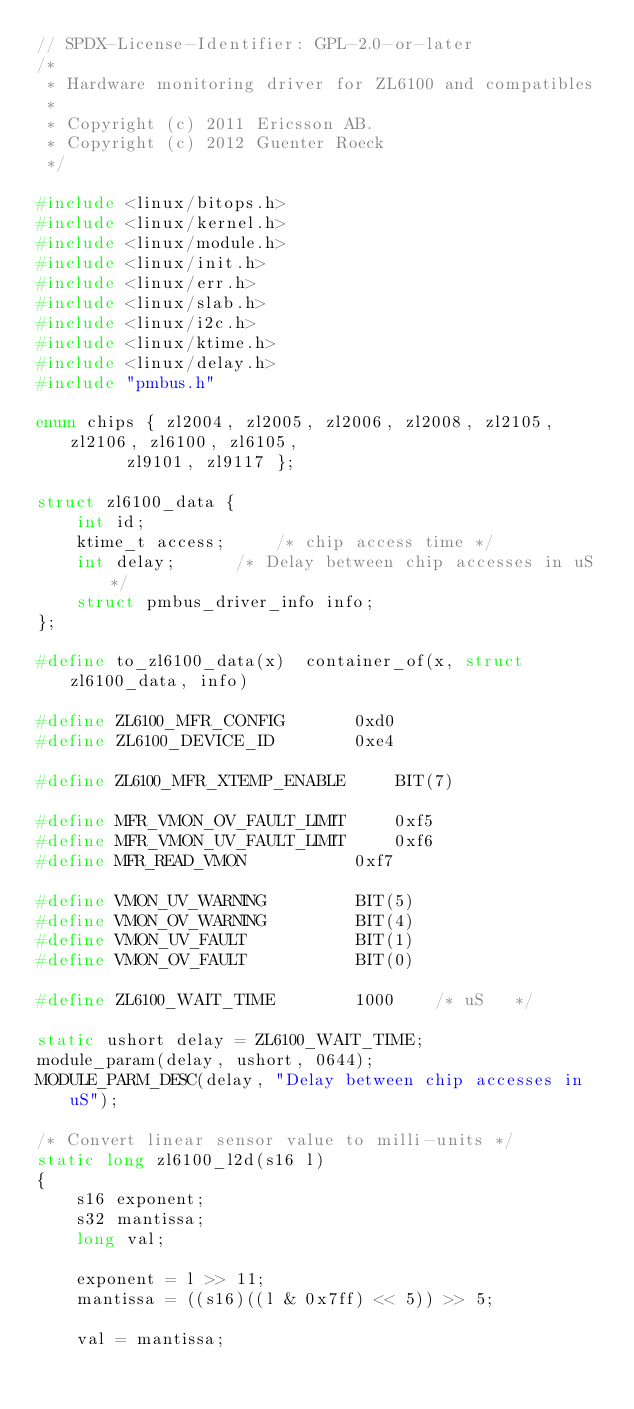Convert code to text. <code><loc_0><loc_0><loc_500><loc_500><_C_>// SPDX-License-Identifier: GPL-2.0-or-later
/*
 * Hardware monitoring driver for ZL6100 and compatibles
 *
 * Copyright (c) 2011 Ericsson AB.
 * Copyright (c) 2012 Guenter Roeck
 */

#include <linux/bitops.h>
#include <linux/kernel.h>
#include <linux/module.h>
#include <linux/init.h>
#include <linux/err.h>
#include <linux/slab.h>
#include <linux/i2c.h>
#include <linux/ktime.h>
#include <linux/delay.h>
#include "pmbus.h"

enum chips { zl2004, zl2005, zl2006, zl2008, zl2105, zl2106, zl6100, zl6105,
	     zl9101, zl9117 };

struct zl6100_data {
	int id;
	ktime_t access;		/* chip access time */
	int delay;		/* Delay between chip accesses in uS */
	struct pmbus_driver_info info;
};

#define to_zl6100_data(x)  container_of(x, struct zl6100_data, info)

#define ZL6100_MFR_CONFIG		0xd0
#define ZL6100_DEVICE_ID		0xe4

#define ZL6100_MFR_XTEMP_ENABLE		BIT(7)

#define MFR_VMON_OV_FAULT_LIMIT		0xf5
#define MFR_VMON_UV_FAULT_LIMIT		0xf6
#define MFR_READ_VMON			0xf7

#define VMON_UV_WARNING			BIT(5)
#define VMON_OV_WARNING			BIT(4)
#define VMON_UV_FAULT			BIT(1)
#define VMON_OV_FAULT			BIT(0)

#define ZL6100_WAIT_TIME		1000	/* uS	*/

static ushort delay = ZL6100_WAIT_TIME;
module_param(delay, ushort, 0644);
MODULE_PARM_DESC(delay, "Delay between chip accesses in uS");

/* Convert linear sensor value to milli-units */
static long zl6100_l2d(s16 l)
{
	s16 exponent;
	s32 mantissa;
	long val;

	exponent = l >> 11;
	mantissa = ((s16)((l & 0x7ff) << 5)) >> 5;

	val = mantissa;
</code> 